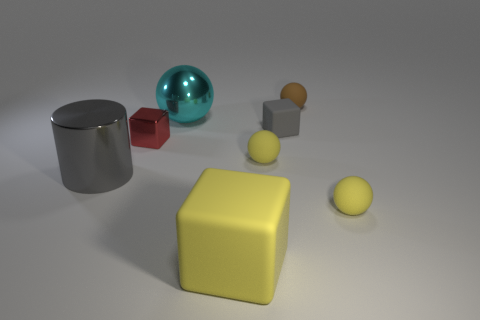Add 2 red things. How many objects exist? 10 Subtract all cylinders. How many objects are left? 7 Add 5 big yellow rubber objects. How many big yellow rubber objects are left? 6 Add 2 large gray blocks. How many large gray blocks exist? 2 Subtract 1 brown spheres. How many objects are left? 7 Subtract all small yellow matte blocks. Subtract all large gray cylinders. How many objects are left? 7 